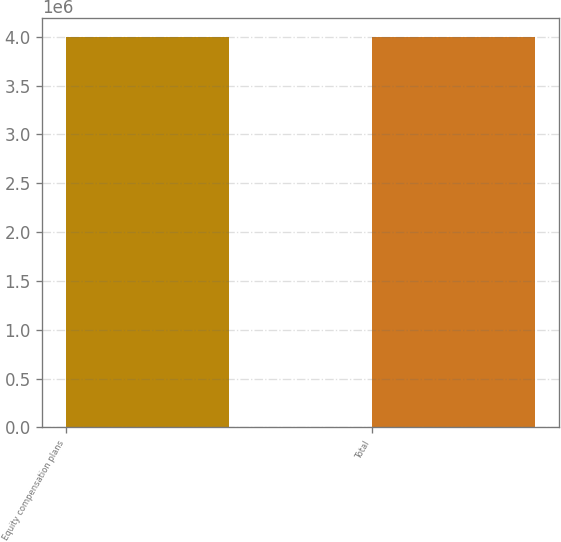Convert chart. <chart><loc_0><loc_0><loc_500><loc_500><bar_chart><fcel>Equity compensation plans<fcel>Total<nl><fcel>3.9956e+06<fcel>3.9956e+06<nl></chart> 